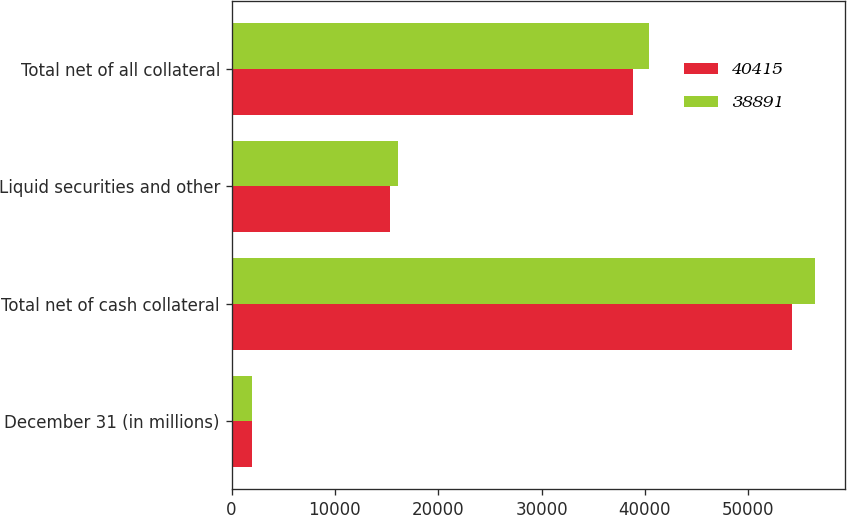Convert chart to OTSL. <chart><loc_0><loc_0><loc_500><loc_500><stacked_bar_chart><ecel><fcel>December 31 (in millions)<fcel>Total net of cash collateral<fcel>Liquid securities and other<fcel>Total net of all collateral<nl><fcel>40415<fcel>2018<fcel>54213<fcel>15322<fcel>38891<nl><fcel>38891<fcel>2017<fcel>56523<fcel>16108<fcel>40415<nl></chart> 